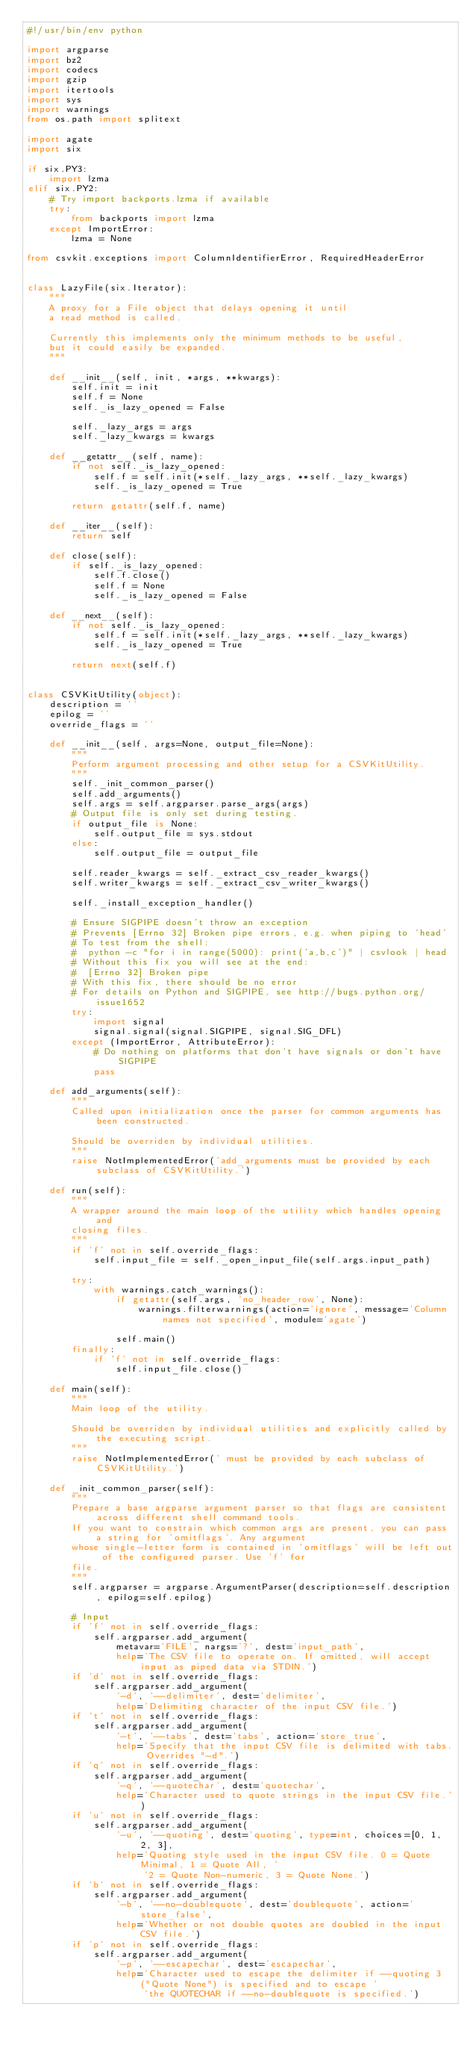<code> <loc_0><loc_0><loc_500><loc_500><_Python_>#!/usr/bin/env python

import argparse
import bz2
import codecs
import gzip
import itertools
import sys
import warnings
from os.path import splitext

import agate
import six

if six.PY3:
    import lzma
elif six.PY2:
    # Try import backports.lzma if available
    try:
        from backports import lzma
    except ImportError:
        lzma = None

from csvkit.exceptions import ColumnIdentifierError, RequiredHeaderError


class LazyFile(six.Iterator):
    """
    A proxy for a File object that delays opening it until
    a read method is called.

    Currently this implements only the minimum methods to be useful,
    but it could easily be expanded.
    """

    def __init__(self, init, *args, **kwargs):
        self.init = init
        self.f = None
        self._is_lazy_opened = False

        self._lazy_args = args
        self._lazy_kwargs = kwargs

    def __getattr__(self, name):
        if not self._is_lazy_opened:
            self.f = self.init(*self._lazy_args, **self._lazy_kwargs)
            self._is_lazy_opened = True

        return getattr(self.f, name)

    def __iter__(self):
        return self

    def close(self):
        if self._is_lazy_opened:
            self.f.close()
            self.f = None
            self._is_lazy_opened = False

    def __next__(self):
        if not self._is_lazy_opened:
            self.f = self.init(*self._lazy_args, **self._lazy_kwargs)
            self._is_lazy_opened = True

        return next(self.f)


class CSVKitUtility(object):
    description = ''
    epilog = ''
    override_flags = ''

    def __init__(self, args=None, output_file=None):
        """
        Perform argument processing and other setup for a CSVKitUtility.
        """
        self._init_common_parser()
        self.add_arguments()
        self.args = self.argparser.parse_args(args)
        # Output file is only set during testing.
        if output_file is None:
            self.output_file = sys.stdout
        else:
            self.output_file = output_file

        self.reader_kwargs = self._extract_csv_reader_kwargs()
        self.writer_kwargs = self._extract_csv_writer_kwargs()

        self._install_exception_handler()

        # Ensure SIGPIPE doesn't throw an exception
        # Prevents [Errno 32] Broken pipe errors, e.g. when piping to 'head'
        # To test from the shell:
        #  python -c "for i in range(5000): print('a,b,c')" | csvlook | head
        # Without this fix you will see at the end:
        #  [Errno 32] Broken pipe
        # With this fix, there should be no error
        # For details on Python and SIGPIPE, see http://bugs.python.org/issue1652
        try:
            import signal
            signal.signal(signal.SIGPIPE, signal.SIG_DFL)
        except (ImportError, AttributeError):
            # Do nothing on platforms that don't have signals or don't have SIGPIPE
            pass

    def add_arguments(self):
        """
        Called upon initialization once the parser for common arguments has been constructed.

        Should be overriden by individual utilities.
        """
        raise NotImplementedError('add_arguments must be provided by each subclass of CSVKitUtility.')

    def run(self):
        """
        A wrapper around the main loop of the utility which handles opening and
        closing files.
        """
        if 'f' not in self.override_flags:
            self.input_file = self._open_input_file(self.args.input_path)

        try:
            with warnings.catch_warnings():
                if getattr(self.args, 'no_header_row', None):
                    warnings.filterwarnings(action='ignore', message='Column names not specified', module='agate')

                self.main()
        finally:
            if 'f' not in self.override_flags:
                self.input_file.close()

    def main(self):
        """
        Main loop of the utility.

        Should be overriden by individual utilities and explicitly called by the executing script.
        """
        raise NotImplementedError(' must be provided by each subclass of CSVKitUtility.')

    def _init_common_parser(self):
        """
        Prepare a base argparse argument parser so that flags are consistent across different shell command tools.
        If you want to constrain which common args are present, you can pass a string for 'omitflags'. Any argument
        whose single-letter form is contained in 'omitflags' will be left out of the configured parser. Use 'f' for
        file.
        """
        self.argparser = argparse.ArgumentParser(description=self.description, epilog=self.epilog)

        # Input
        if 'f' not in self.override_flags:
            self.argparser.add_argument(
                metavar='FILE', nargs='?', dest='input_path',
                help='The CSV file to operate on. If omitted, will accept input as piped data via STDIN.')
        if 'd' not in self.override_flags:
            self.argparser.add_argument(
                '-d', '--delimiter', dest='delimiter',
                help='Delimiting character of the input CSV file.')
        if 't' not in self.override_flags:
            self.argparser.add_argument(
                '-t', '--tabs', dest='tabs', action='store_true',
                help='Specify that the input CSV file is delimited with tabs. Overrides "-d".')
        if 'q' not in self.override_flags:
            self.argparser.add_argument(
                '-q', '--quotechar', dest='quotechar',
                help='Character used to quote strings in the input CSV file.')
        if 'u' not in self.override_flags:
            self.argparser.add_argument(
                '-u', '--quoting', dest='quoting', type=int, choices=[0, 1, 2, 3],
                help='Quoting style used in the input CSV file. 0 = Quote Minimal, 1 = Quote All, '
                     '2 = Quote Non-numeric, 3 = Quote None.')
        if 'b' not in self.override_flags:
            self.argparser.add_argument(
                '-b', '--no-doublequote', dest='doublequote', action='store_false',
                help='Whether or not double quotes are doubled in the input CSV file.')
        if 'p' not in self.override_flags:
            self.argparser.add_argument(
                '-p', '--escapechar', dest='escapechar',
                help='Character used to escape the delimiter if --quoting 3 ("Quote None") is specified and to escape '
                     'the QUOTECHAR if --no-doublequote is specified.')</code> 